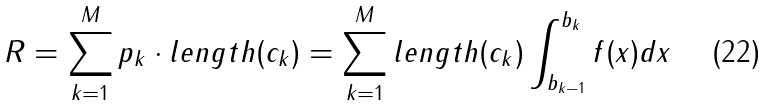<formula> <loc_0><loc_0><loc_500><loc_500>R = \sum _ { k = 1 } ^ { M } p _ { k } \cdot l e n g t h ( c _ { k } ) = \sum _ { k = 1 } ^ { M } l e n g t h ( c _ { k } ) \int _ { b _ { k - 1 } } ^ { b _ { k } } f ( x ) d x</formula> 